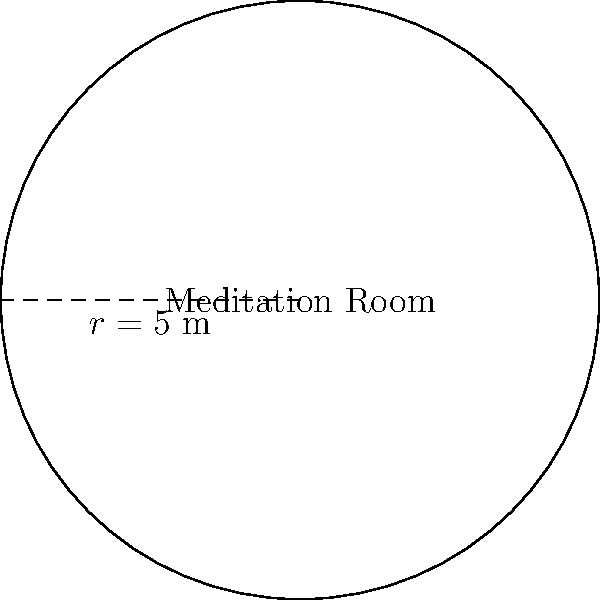A circular meditation room in your wellness center has a radius of 5 meters. What is the area of this room, rounded to the nearest square meter? To find the area of a circular room, we use the formula:

$$A = \pi r^2$$

Where:
$A$ = area
$\pi$ = pi (approximately 3.14159)
$r$ = radius

Given:
$r = 5$ meters

Step 1: Substitute the values into the formula
$$A = \pi (5)^2$$

Step 2: Calculate the square of the radius
$$A = \pi (25)$$

Step 3: Multiply by pi
$$A = 3.14159 \times 25 = 78.53975$$

Step 4: Round to the nearest square meter
$$A \approx 79 \text{ m}^2$$
Answer: 79 m² 